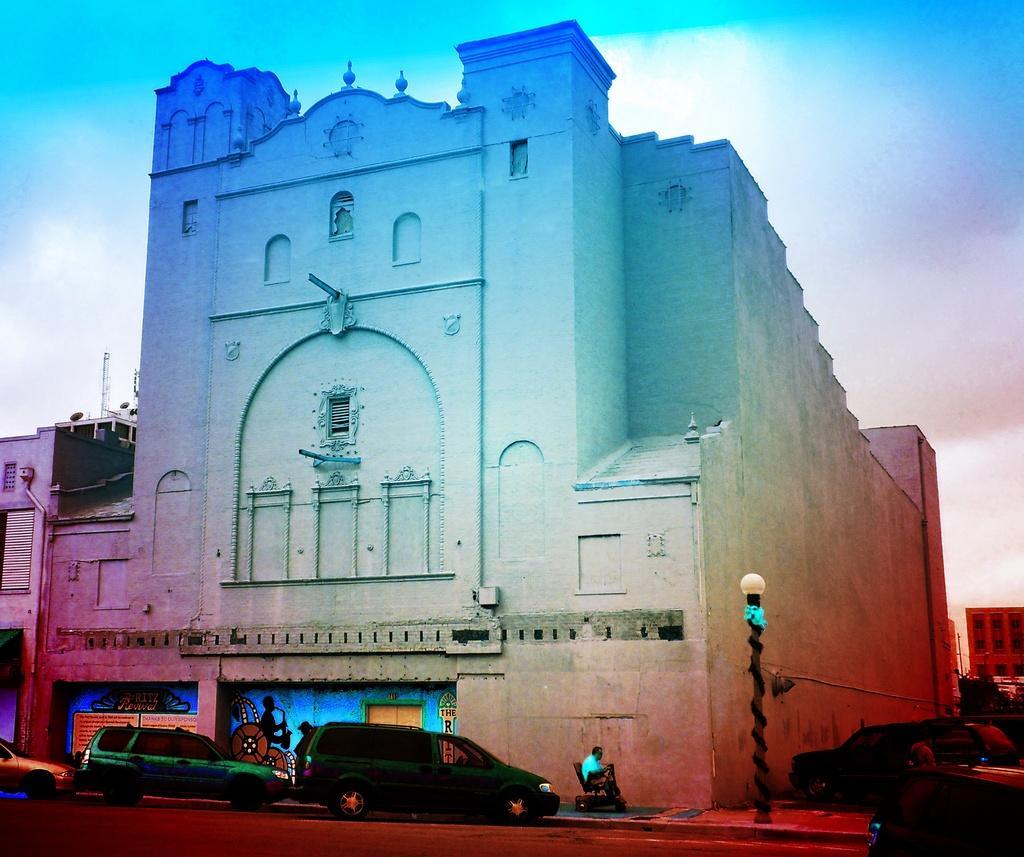Describe this image in one or two sentences. In this picture, there is a building in the center. At the bottom left, there are vehicles which are in different colors. In the center there is a man sitting on the wheelchair. Before him, there is a pole with light. In the background, there is a sky with clouds. 